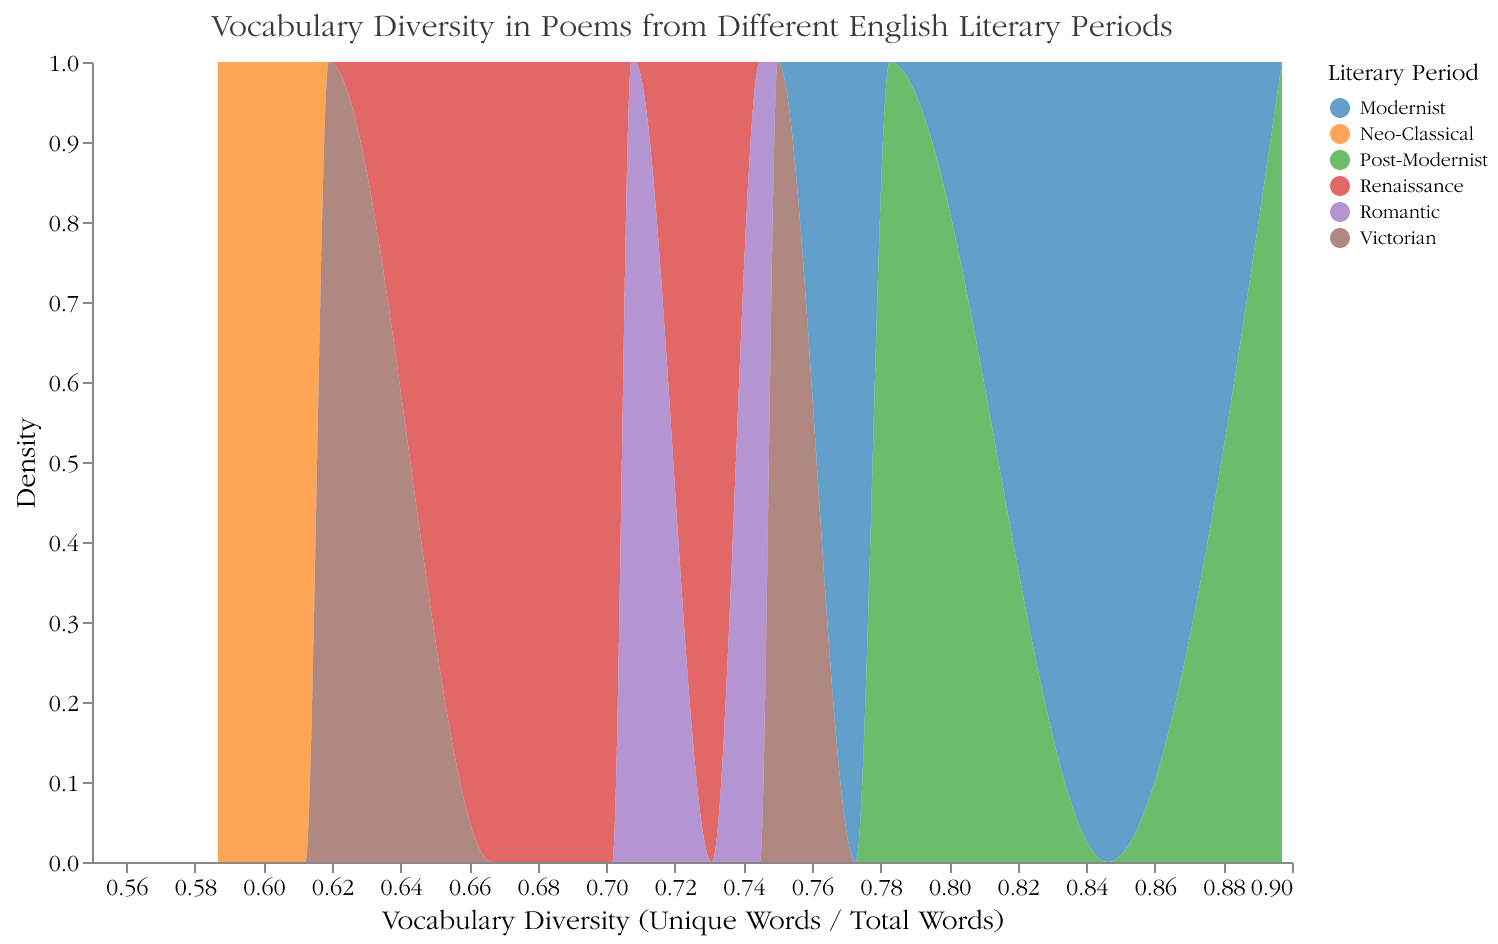What's the title of the figure? The title of the figure is displayed at the top of the plot and reads "Vocabulary Diversity in Poems from Different English Literary Periods."
Answer: Vocabulary Diversity in Poems from Different English Literary Periods How many literary periods are represented in the figure? The legend at the right side of the figure uses different colors to represent each literary period, showing six different literary periods.
Answer: Six What is plotted on the x-axis and y-axis? The x-axis represents "Vocabulary Diversity (Unique Words / Total Words)," while the y-axis shows "Density."
Answer: Vocabulary Diversity on x-axis and Density on y-axis Which literary period has the poem with the highest vocabulary diversity? By inspecting the density plot and the legend colors, the poem with the highest vocabulary diversity belongs to the Post-Modernist period.
Answer: Post-Modernist What is the range of vocabulary diversity values displayed on the x-axis? The x-axis presents vocabulary diversity values, ranging from around 0.4 to 0.9.
Answer: 0.4 to 0.9 Which period shows the largest spread in vocabulary diversity? The Post-Modernist period shows the widest spread in vocabulary diversity, as indicated by a wide distribution in its density plot.
Answer: Post-Modernist Which two periods have the densest regions of vocabulary diversity around 0.6? By observing the density curves, the Neo-Classical and Victorian periods have the densest areas around a vocabulary diversity of 0.6.
Answer: Neo-Classical and Victorian Compare the vocabulary diversity density peak of the Renaissance and Romantic periods. Which one is higher? From the density plot, the Romantic period has a higher peak density compared to the Renaissance period.
Answer: Romantic What is the general trend of vocabulary diversity across different literary periods? Comparing the density plots across the periods, vocabulary diversity generally increases from Renaissance to Post-Modernist periods.
Answer: Increasing trend What is the approximate vocabulary diversity value where the Modernist period peaks? By observing the figure, the highest density peak for the Modernist period appears to be around 0.85.
Answer: 0.85 